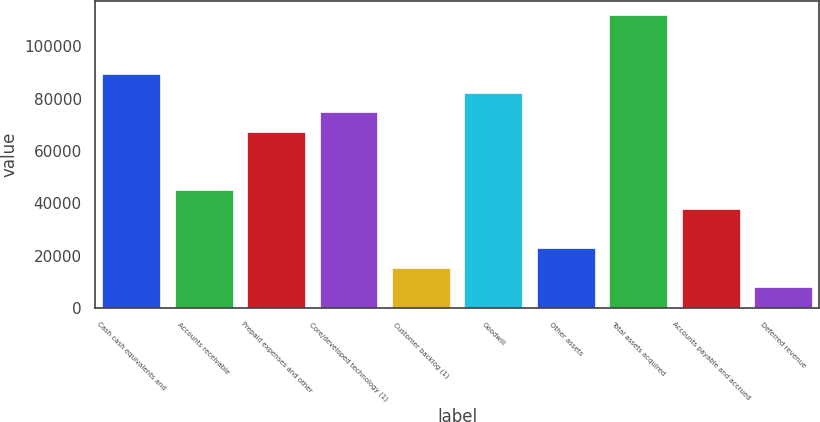Convert chart to OTSL. <chart><loc_0><loc_0><loc_500><loc_500><bar_chart><fcel>Cash cash equivalents and<fcel>Accounts receivable<fcel>Prepaid expenses and other<fcel>Core/developed technology (1)<fcel>Customer backlog (1)<fcel>Goodwill<fcel>Other assets<fcel>Total assets acquired<fcel>Accounts payable and accrued<fcel>Deferred revenue<nl><fcel>89594.2<fcel>45028.6<fcel>67311.4<fcel>74739<fcel>15318.2<fcel>82166.6<fcel>22745.8<fcel>111877<fcel>37601<fcel>7890.6<nl></chart> 